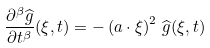Convert formula to latex. <formula><loc_0><loc_0><loc_500><loc_500>\frac { \partial ^ { \beta } \widehat { g } } { \partial t ^ { \beta } } ( \xi , t ) = - \left ( a \cdot \xi \right ) ^ { 2 } \, \widehat { g } ( \xi , t )</formula> 